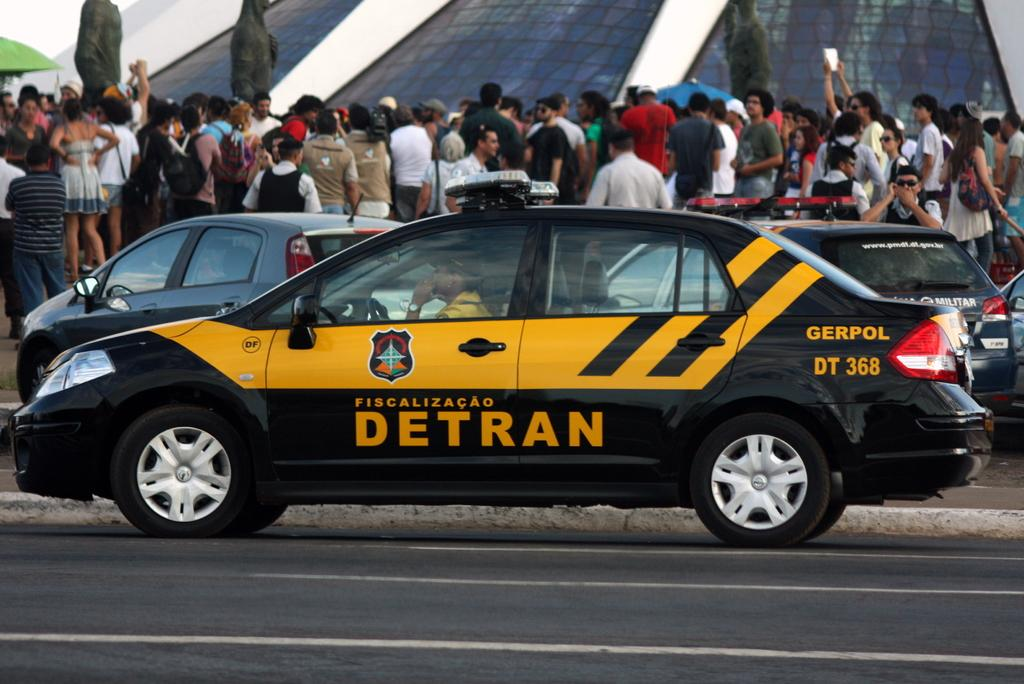Provide a one-sentence caption for the provided image. A black/yellow car with the sign DETRAN on the door. 